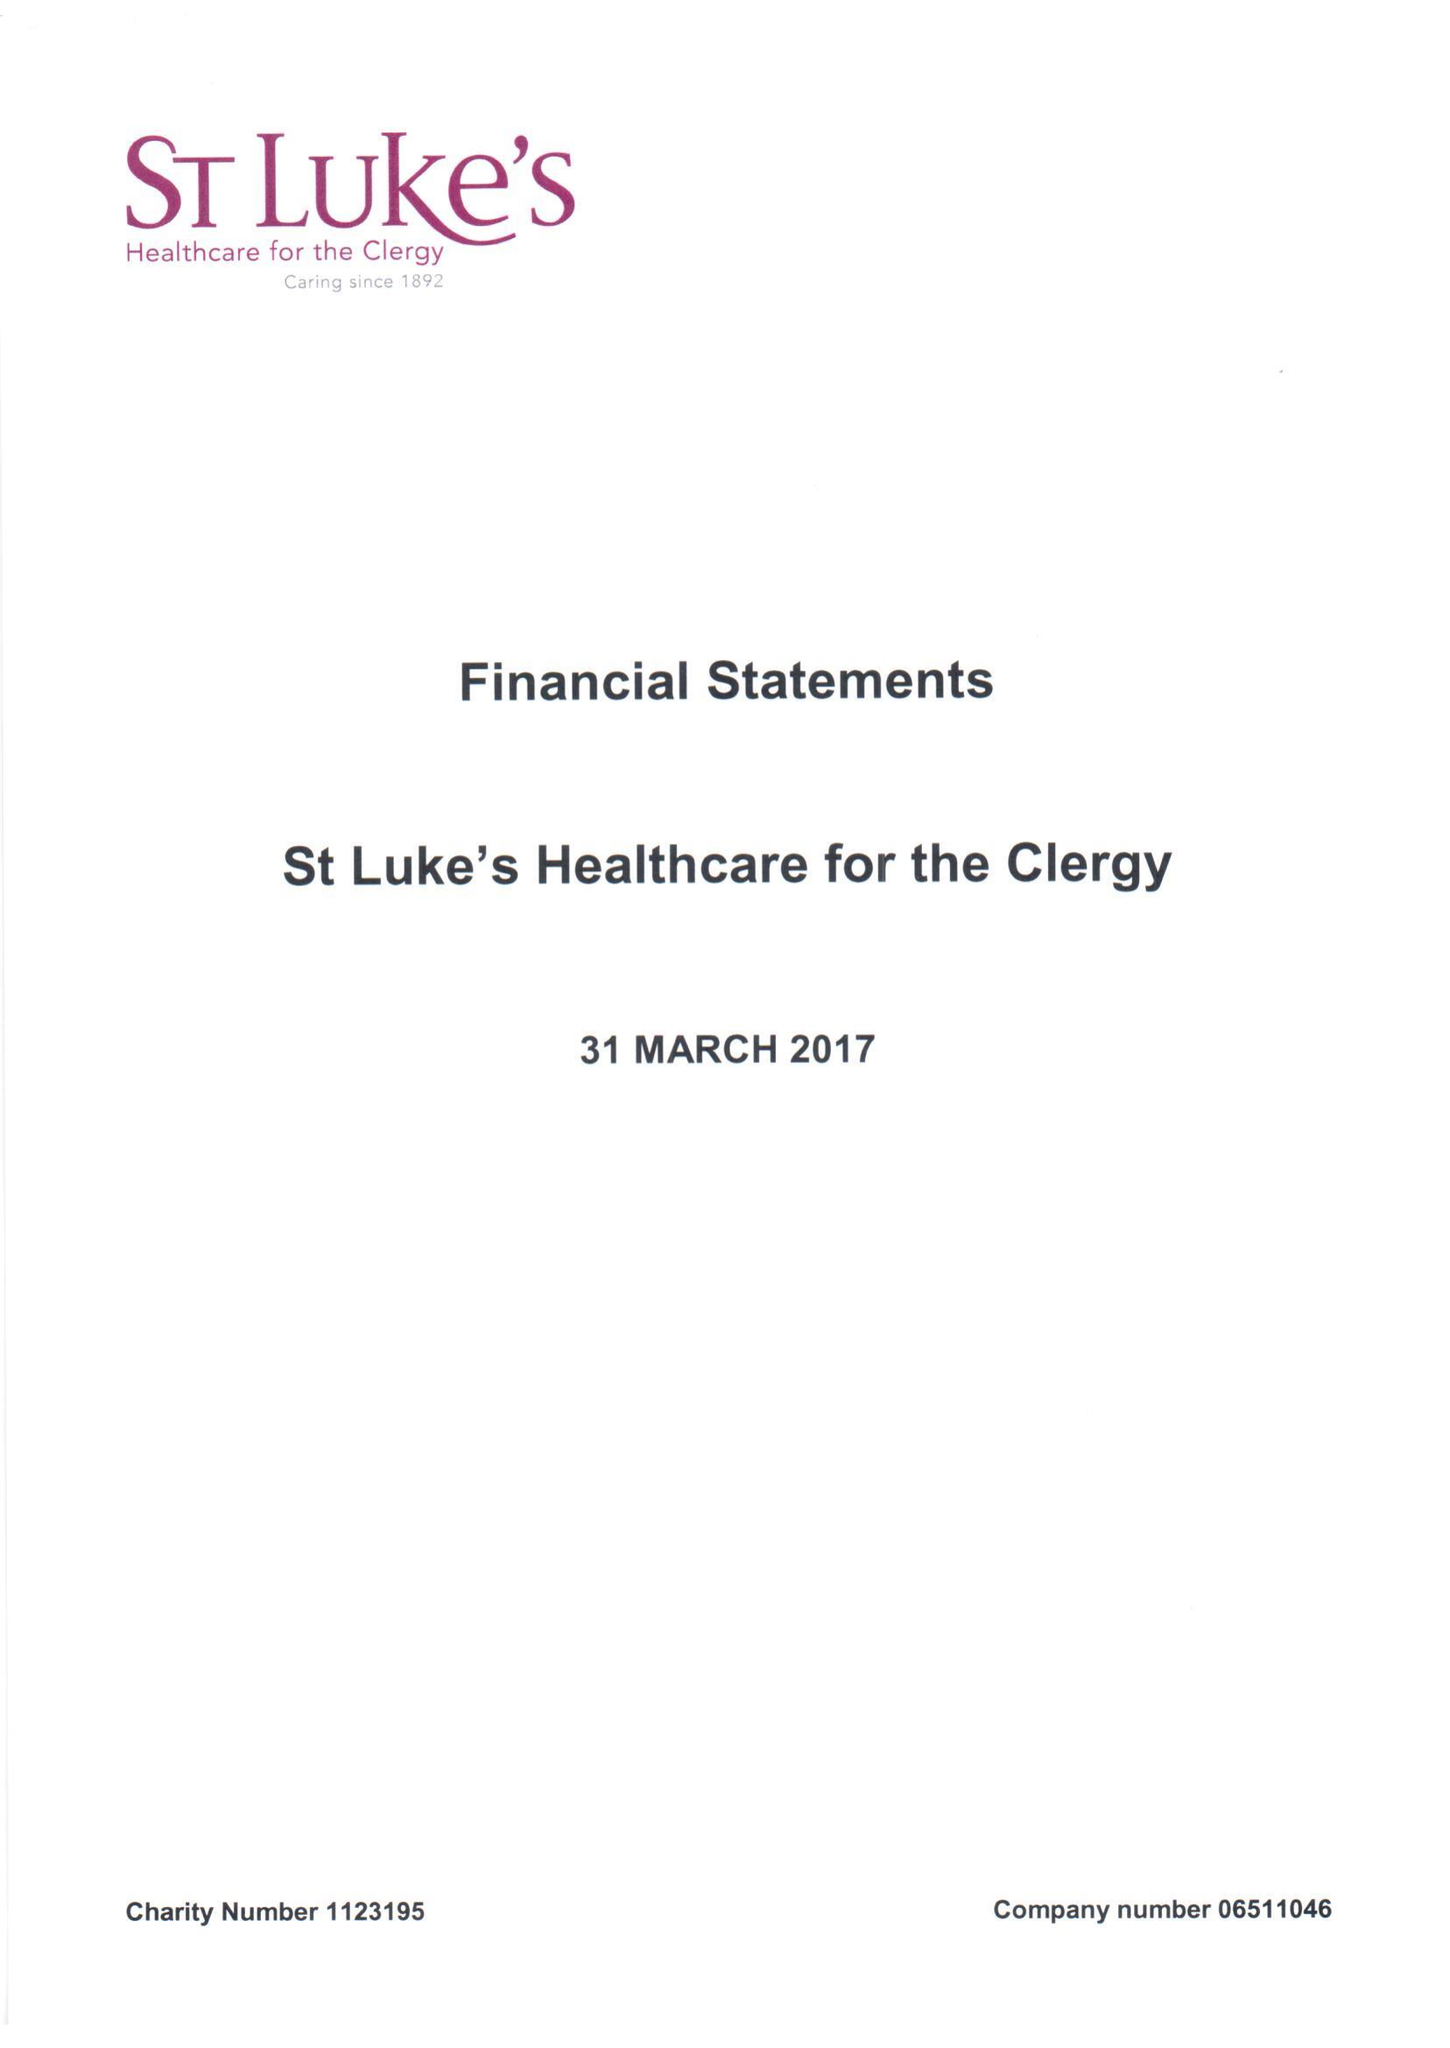What is the value for the address__postcode?
Answer the question using a single word or phrase. SW1P 3AZ 